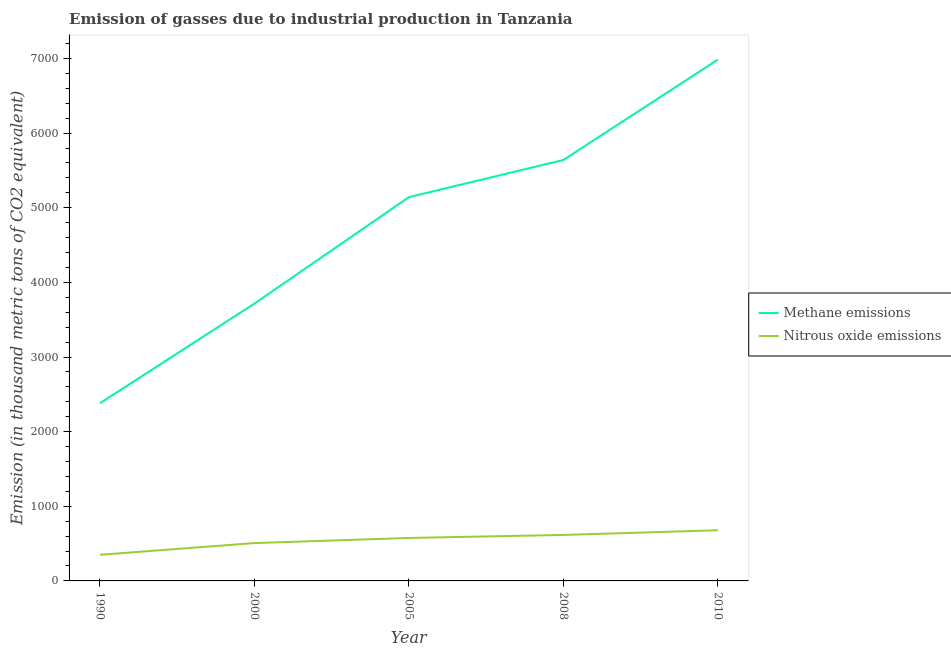Does the line corresponding to amount of methane emissions intersect with the line corresponding to amount of nitrous oxide emissions?
Your answer should be very brief. No. Is the number of lines equal to the number of legend labels?
Your response must be concise. Yes. What is the amount of methane emissions in 2005?
Provide a short and direct response. 5142.2. Across all years, what is the maximum amount of methane emissions?
Your answer should be compact. 6984.5. Across all years, what is the minimum amount of methane emissions?
Provide a succinct answer. 2380.6. In which year was the amount of nitrous oxide emissions minimum?
Your answer should be very brief. 1990. What is the total amount of methane emissions in the graph?
Offer a very short reply. 2.39e+04. What is the difference between the amount of methane emissions in 2005 and that in 2010?
Give a very brief answer. -1842.3. What is the difference between the amount of methane emissions in 2010 and the amount of nitrous oxide emissions in 2000?
Provide a short and direct response. 6477.4. What is the average amount of nitrous oxide emissions per year?
Your response must be concise. 545.62. In the year 2005, what is the difference between the amount of nitrous oxide emissions and amount of methane emissions?
Offer a very short reply. -4566.5. What is the ratio of the amount of nitrous oxide emissions in 2005 to that in 2010?
Your answer should be very brief. 0.85. Is the amount of methane emissions in 1990 less than that in 2005?
Provide a succinct answer. Yes. What is the difference between the highest and the second highest amount of methane emissions?
Provide a succinct answer. 1344.6. What is the difference between the highest and the lowest amount of methane emissions?
Your answer should be compact. 4603.9. Is the amount of nitrous oxide emissions strictly less than the amount of methane emissions over the years?
Your answer should be compact. Yes. How many lines are there?
Provide a succinct answer. 2. How many years are there in the graph?
Keep it short and to the point. 5. What is the difference between two consecutive major ticks on the Y-axis?
Make the answer very short. 1000. Does the graph contain grids?
Ensure brevity in your answer.  No. How many legend labels are there?
Keep it short and to the point. 2. What is the title of the graph?
Provide a short and direct response. Emission of gasses due to industrial production in Tanzania. What is the label or title of the Y-axis?
Offer a very short reply. Emission (in thousand metric tons of CO2 equivalent). What is the Emission (in thousand metric tons of CO2 equivalent) of Methane emissions in 1990?
Offer a very short reply. 2380.6. What is the Emission (in thousand metric tons of CO2 equivalent) in Nitrous oxide emissions in 1990?
Offer a terse response. 350.1. What is the Emission (in thousand metric tons of CO2 equivalent) in Methane emissions in 2000?
Offer a very short reply. 3716.1. What is the Emission (in thousand metric tons of CO2 equivalent) of Nitrous oxide emissions in 2000?
Provide a succinct answer. 507.1. What is the Emission (in thousand metric tons of CO2 equivalent) in Methane emissions in 2005?
Keep it short and to the point. 5142.2. What is the Emission (in thousand metric tons of CO2 equivalent) in Nitrous oxide emissions in 2005?
Give a very brief answer. 575.7. What is the Emission (in thousand metric tons of CO2 equivalent) in Methane emissions in 2008?
Provide a succinct answer. 5639.9. What is the Emission (in thousand metric tons of CO2 equivalent) in Nitrous oxide emissions in 2008?
Offer a terse response. 616.2. What is the Emission (in thousand metric tons of CO2 equivalent) of Methane emissions in 2010?
Offer a terse response. 6984.5. What is the Emission (in thousand metric tons of CO2 equivalent) of Nitrous oxide emissions in 2010?
Offer a very short reply. 679. Across all years, what is the maximum Emission (in thousand metric tons of CO2 equivalent) of Methane emissions?
Provide a short and direct response. 6984.5. Across all years, what is the maximum Emission (in thousand metric tons of CO2 equivalent) in Nitrous oxide emissions?
Offer a very short reply. 679. Across all years, what is the minimum Emission (in thousand metric tons of CO2 equivalent) of Methane emissions?
Offer a very short reply. 2380.6. Across all years, what is the minimum Emission (in thousand metric tons of CO2 equivalent) in Nitrous oxide emissions?
Provide a succinct answer. 350.1. What is the total Emission (in thousand metric tons of CO2 equivalent) of Methane emissions in the graph?
Offer a terse response. 2.39e+04. What is the total Emission (in thousand metric tons of CO2 equivalent) of Nitrous oxide emissions in the graph?
Provide a succinct answer. 2728.1. What is the difference between the Emission (in thousand metric tons of CO2 equivalent) of Methane emissions in 1990 and that in 2000?
Offer a very short reply. -1335.5. What is the difference between the Emission (in thousand metric tons of CO2 equivalent) of Nitrous oxide emissions in 1990 and that in 2000?
Provide a short and direct response. -157. What is the difference between the Emission (in thousand metric tons of CO2 equivalent) in Methane emissions in 1990 and that in 2005?
Your answer should be compact. -2761.6. What is the difference between the Emission (in thousand metric tons of CO2 equivalent) in Nitrous oxide emissions in 1990 and that in 2005?
Ensure brevity in your answer.  -225.6. What is the difference between the Emission (in thousand metric tons of CO2 equivalent) in Methane emissions in 1990 and that in 2008?
Give a very brief answer. -3259.3. What is the difference between the Emission (in thousand metric tons of CO2 equivalent) in Nitrous oxide emissions in 1990 and that in 2008?
Your answer should be very brief. -266.1. What is the difference between the Emission (in thousand metric tons of CO2 equivalent) in Methane emissions in 1990 and that in 2010?
Your response must be concise. -4603.9. What is the difference between the Emission (in thousand metric tons of CO2 equivalent) of Nitrous oxide emissions in 1990 and that in 2010?
Give a very brief answer. -328.9. What is the difference between the Emission (in thousand metric tons of CO2 equivalent) of Methane emissions in 2000 and that in 2005?
Provide a succinct answer. -1426.1. What is the difference between the Emission (in thousand metric tons of CO2 equivalent) in Nitrous oxide emissions in 2000 and that in 2005?
Offer a terse response. -68.6. What is the difference between the Emission (in thousand metric tons of CO2 equivalent) in Methane emissions in 2000 and that in 2008?
Give a very brief answer. -1923.8. What is the difference between the Emission (in thousand metric tons of CO2 equivalent) in Nitrous oxide emissions in 2000 and that in 2008?
Your answer should be compact. -109.1. What is the difference between the Emission (in thousand metric tons of CO2 equivalent) of Methane emissions in 2000 and that in 2010?
Provide a succinct answer. -3268.4. What is the difference between the Emission (in thousand metric tons of CO2 equivalent) of Nitrous oxide emissions in 2000 and that in 2010?
Give a very brief answer. -171.9. What is the difference between the Emission (in thousand metric tons of CO2 equivalent) in Methane emissions in 2005 and that in 2008?
Offer a very short reply. -497.7. What is the difference between the Emission (in thousand metric tons of CO2 equivalent) of Nitrous oxide emissions in 2005 and that in 2008?
Keep it short and to the point. -40.5. What is the difference between the Emission (in thousand metric tons of CO2 equivalent) in Methane emissions in 2005 and that in 2010?
Your response must be concise. -1842.3. What is the difference between the Emission (in thousand metric tons of CO2 equivalent) in Nitrous oxide emissions in 2005 and that in 2010?
Offer a very short reply. -103.3. What is the difference between the Emission (in thousand metric tons of CO2 equivalent) in Methane emissions in 2008 and that in 2010?
Offer a terse response. -1344.6. What is the difference between the Emission (in thousand metric tons of CO2 equivalent) in Nitrous oxide emissions in 2008 and that in 2010?
Your response must be concise. -62.8. What is the difference between the Emission (in thousand metric tons of CO2 equivalent) in Methane emissions in 1990 and the Emission (in thousand metric tons of CO2 equivalent) in Nitrous oxide emissions in 2000?
Your answer should be very brief. 1873.5. What is the difference between the Emission (in thousand metric tons of CO2 equivalent) of Methane emissions in 1990 and the Emission (in thousand metric tons of CO2 equivalent) of Nitrous oxide emissions in 2005?
Keep it short and to the point. 1804.9. What is the difference between the Emission (in thousand metric tons of CO2 equivalent) of Methane emissions in 1990 and the Emission (in thousand metric tons of CO2 equivalent) of Nitrous oxide emissions in 2008?
Offer a very short reply. 1764.4. What is the difference between the Emission (in thousand metric tons of CO2 equivalent) in Methane emissions in 1990 and the Emission (in thousand metric tons of CO2 equivalent) in Nitrous oxide emissions in 2010?
Offer a terse response. 1701.6. What is the difference between the Emission (in thousand metric tons of CO2 equivalent) of Methane emissions in 2000 and the Emission (in thousand metric tons of CO2 equivalent) of Nitrous oxide emissions in 2005?
Offer a very short reply. 3140.4. What is the difference between the Emission (in thousand metric tons of CO2 equivalent) of Methane emissions in 2000 and the Emission (in thousand metric tons of CO2 equivalent) of Nitrous oxide emissions in 2008?
Offer a terse response. 3099.9. What is the difference between the Emission (in thousand metric tons of CO2 equivalent) in Methane emissions in 2000 and the Emission (in thousand metric tons of CO2 equivalent) in Nitrous oxide emissions in 2010?
Your answer should be compact. 3037.1. What is the difference between the Emission (in thousand metric tons of CO2 equivalent) of Methane emissions in 2005 and the Emission (in thousand metric tons of CO2 equivalent) of Nitrous oxide emissions in 2008?
Give a very brief answer. 4526. What is the difference between the Emission (in thousand metric tons of CO2 equivalent) of Methane emissions in 2005 and the Emission (in thousand metric tons of CO2 equivalent) of Nitrous oxide emissions in 2010?
Provide a short and direct response. 4463.2. What is the difference between the Emission (in thousand metric tons of CO2 equivalent) of Methane emissions in 2008 and the Emission (in thousand metric tons of CO2 equivalent) of Nitrous oxide emissions in 2010?
Provide a short and direct response. 4960.9. What is the average Emission (in thousand metric tons of CO2 equivalent) of Methane emissions per year?
Provide a succinct answer. 4772.66. What is the average Emission (in thousand metric tons of CO2 equivalent) in Nitrous oxide emissions per year?
Offer a terse response. 545.62. In the year 1990, what is the difference between the Emission (in thousand metric tons of CO2 equivalent) in Methane emissions and Emission (in thousand metric tons of CO2 equivalent) in Nitrous oxide emissions?
Provide a short and direct response. 2030.5. In the year 2000, what is the difference between the Emission (in thousand metric tons of CO2 equivalent) in Methane emissions and Emission (in thousand metric tons of CO2 equivalent) in Nitrous oxide emissions?
Give a very brief answer. 3209. In the year 2005, what is the difference between the Emission (in thousand metric tons of CO2 equivalent) of Methane emissions and Emission (in thousand metric tons of CO2 equivalent) of Nitrous oxide emissions?
Give a very brief answer. 4566.5. In the year 2008, what is the difference between the Emission (in thousand metric tons of CO2 equivalent) in Methane emissions and Emission (in thousand metric tons of CO2 equivalent) in Nitrous oxide emissions?
Your answer should be very brief. 5023.7. In the year 2010, what is the difference between the Emission (in thousand metric tons of CO2 equivalent) in Methane emissions and Emission (in thousand metric tons of CO2 equivalent) in Nitrous oxide emissions?
Keep it short and to the point. 6305.5. What is the ratio of the Emission (in thousand metric tons of CO2 equivalent) of Methane emissions in 1990 to that in 2000?
Offer a very short reply. 0.64. What is the ratio of the Emission (in thousand metric tons of CO2 equivalent) in Nitrous oxide emissions in 1990 to that in 2000?
Give a very brief answer. 0.69. What is the ratio of the Emission (in thousand metric tons of CO2 equivalent) in Methane emissions in 1990 to that in 2005?
Your answer should be very brief. 0.46. What is the ratio of the Emission (in thousand metric tons of CO2 equivalent) of Nitrous oxide emissions in 1990 to that in 2005?
Offer a terse response. 0.61. What is the ratio of the Emission (in thousand metric tons of CO2 equivalent) in Methane emissions in 1990 to that in 2008?
Your answer should be very brief. 0.42. What is the ratio of the Emission (in thousand metric tons of CO2 equivalent) of Nitrous oxide emissions in 1990 to that in 2008?
Give a very brief answer. 0.57. What is the ratio of the Emission (in thousand metric tons of CO2 equivalent) in Methane emissions in 1990 to that in 2010?
Offer a very short reply. 0.34. What is the ratio of the Emission (in thousand metric tons of CO2 equivalent) in Nitrous oxide emissions in 1990 to that in 2010?
Keep it short and to the point. 0.52. What is the ratio of the Emission (in thousand metric tons of CO2 equivalent) of Methane emissions in 2000 to that in 2005?
Your answer should be very brief. 0.72. What is the ratio of the Emission (in thousand metric tons of CO2 equivalent) in Nitrous oxide emissions in 2000 to that in 2005?
Provide a short and direct response. 0.88. What is the ratio of the Emission (in thousand metric tons of CO2 equivalent) of Methane emissions in 2000 to that in 2008?
Ensure brevity in your answer.  0.66. What is the ratio of the Emission (in thousand metric tons of CO2 equivalent) in Nitrous oxide emissions in 2000 to that in 2008?
Your response must be concise. 0.82. What is the ratio of the Emission (in thousand metric tons of CO2 equivalent) of Methane emissions in 2000 to that in 2010?
Make the answer very short. 0.53. What is the ratio of the Emission (in thousand metric tons of CO2 equivalent) in Nitrous oxide emissions in 2000 to that in 2010?
Your response must be concise. 0.75. What is the ratio of the Emission (in thousand metric tons of CO2 equivalent) in Methane emissions in 2005 to that in 2008?
Your answer should be very brief. 0.91. What is the ratio of the Emission (in thousand metric tons of CO2 equivalent) of Nitrous oxide emissions in 2005 to that in 2008?
Keep it short and to the point. 0.93. What is the ratio of the Emission (in thousand metric tons of CO2 equivalent) in Methane emissions in 2005 to that in 2010?
Give a very brief answer. 0.74. What is the ratio of the Emission (in thousand metric tons of CO2 equivalent) in Nitrous oxide emissions in 2005 to that in 2010?
Your response must be concise. 0.85. What is the ratio of the Emission (in thousand metric tons of CO2 equivalent) of Methane emissions in 2008 to that in 2010?
Give a very brief answer. 0.81. What is the ratio of the Emission (in thousand metric tons of CO2 equivalent) in Nitrous oxide emissions in 2008 to that in 2010?
Make the answer very short. 0.91. What is the difference between the highest and the second highest Emission (in thousand metric tons of CO2 equivalent) of Methane emissions?
Provide a succinct answer. 1344.6. What is the difference between the highest and the second highest Emission (in thousand metric tons of CO2 equivalent) of Nitrous oxide emissions?
Your answer should be very brief. 62.8. What is the difference between the highest and the lowest Emission (in thousand metric tons of CO2 equivalent) in Methane emissions?
Ensure brevity in your answer.  4603.9. What is the difference between the highest and the lowest Emission (in thousand metric tons of CO2 equivalent) of Nitrous oxide emissions?
Ensure brevity in your answer.  328.9. 